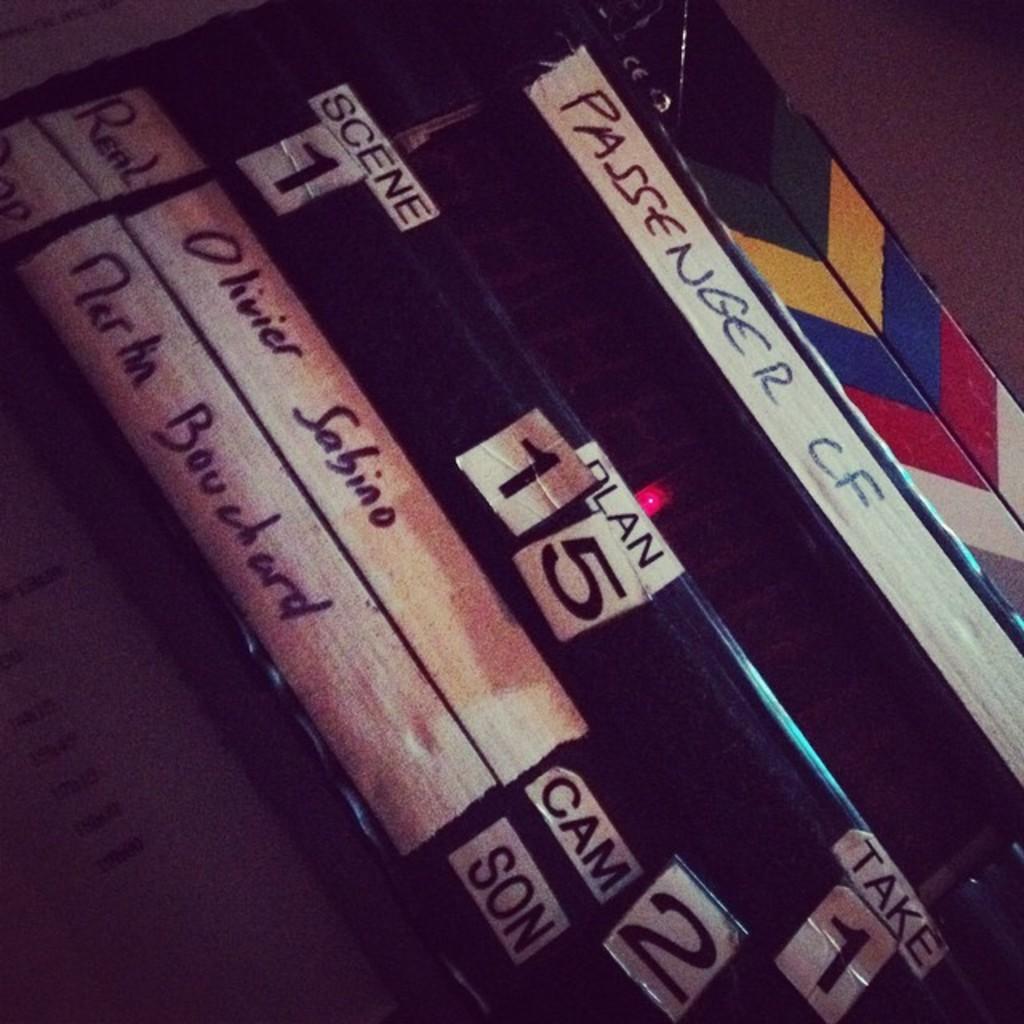Is this the first scene?
Provide a short and direct response. Yes. 